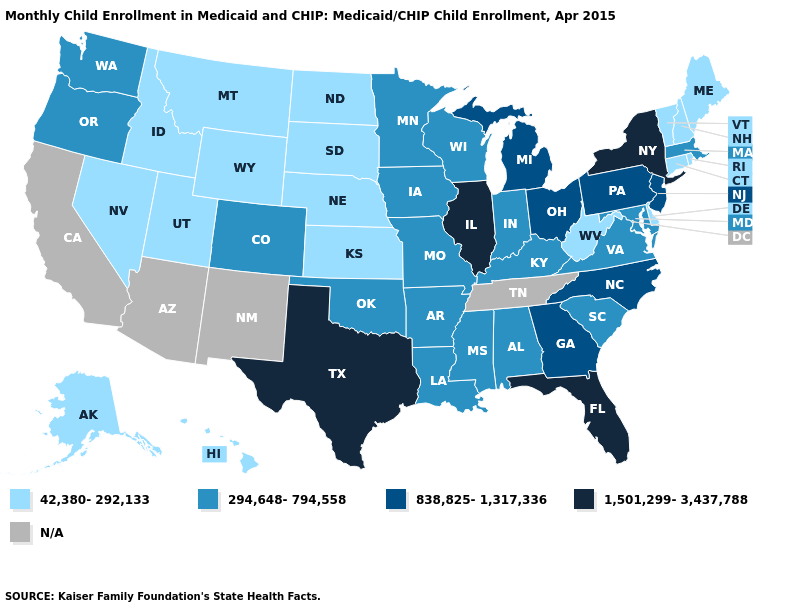Name the states that have a value in the range 838,825-1,317,336?
Write a very short answer. Georgia, Michigan, New Jersey, North Carolina, Ohio, Pennsylvania. What is the value of Maine?
Answer briefly. 42,380-292,133. What is the value of Iowa?
Be succinct. 294,648-794,558. How many symbols are there in the legend?
Write a very short answer. 5. Does the map have missing data?
Give a very brief answer. Yes. Name the states that have a value in the range 838,825-1,317,336?
Answer briefly. Georgia, Michigan, New Jersey, North Carolina, Ohio, Pennsylvania. Name the states that have a value in the range 1,501,299-3,437,788?
Short answer required. Florida, Illinois, New York, Texas. What is the highest value in the USA?
Quick response, please. 1,501,299-3,437,788. Name the states that have a value in the range 294,648-794,558?
Short answer required. Alabama, Arkansas, Colorado, Indiana, Iowa, Kentucky, Louisiana, Maryland, Massachusetts, Minnesota, Mississippi, Missouri, Oklahoma, Oregon, South Carolina, Virginia, Washington, Wisconsin. Name the states that have a value in the range 838,825-1,317,336?
Write a very short answer. Georgia, Michigan, New Jersey, North Carolina, Ohio, Pennsylvania. What is the value of Mississippi?
Answer briefly. 294,648-794,558. Does the map have missing data?
Concise answer only. Yes. What is the value of Florida?
Give a very brief answer. 1,501,299-3,437,788. Among the states that border Arkansas , which have the lowest value?
Give a very brief answer. Louisiana, Mississippi, Missouri, Oklahoma. 